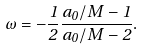Convert formula to latex. <formula><loc_0><loc_0><loc_500><loc_500>\omega = - \frac { 1 } { 2 } \frac { a _ { 0 } / M - 1 } { a _ { 0 } / M - 2 } .</formula> 